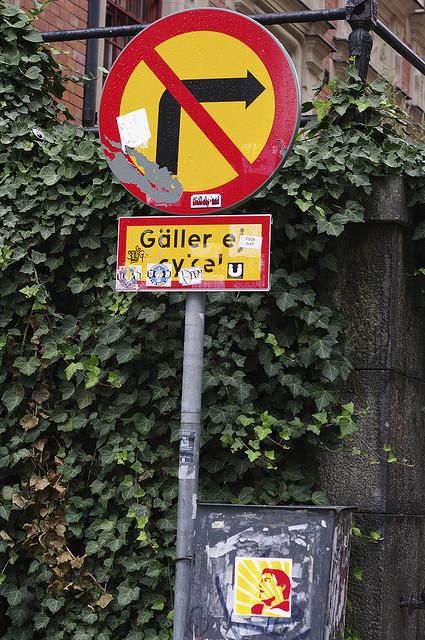Is the sign in English?
Keep it brief. No. Who put the stickers on this sign?
Short answer required. People. Can you turn right?
Concise answer only. No. 